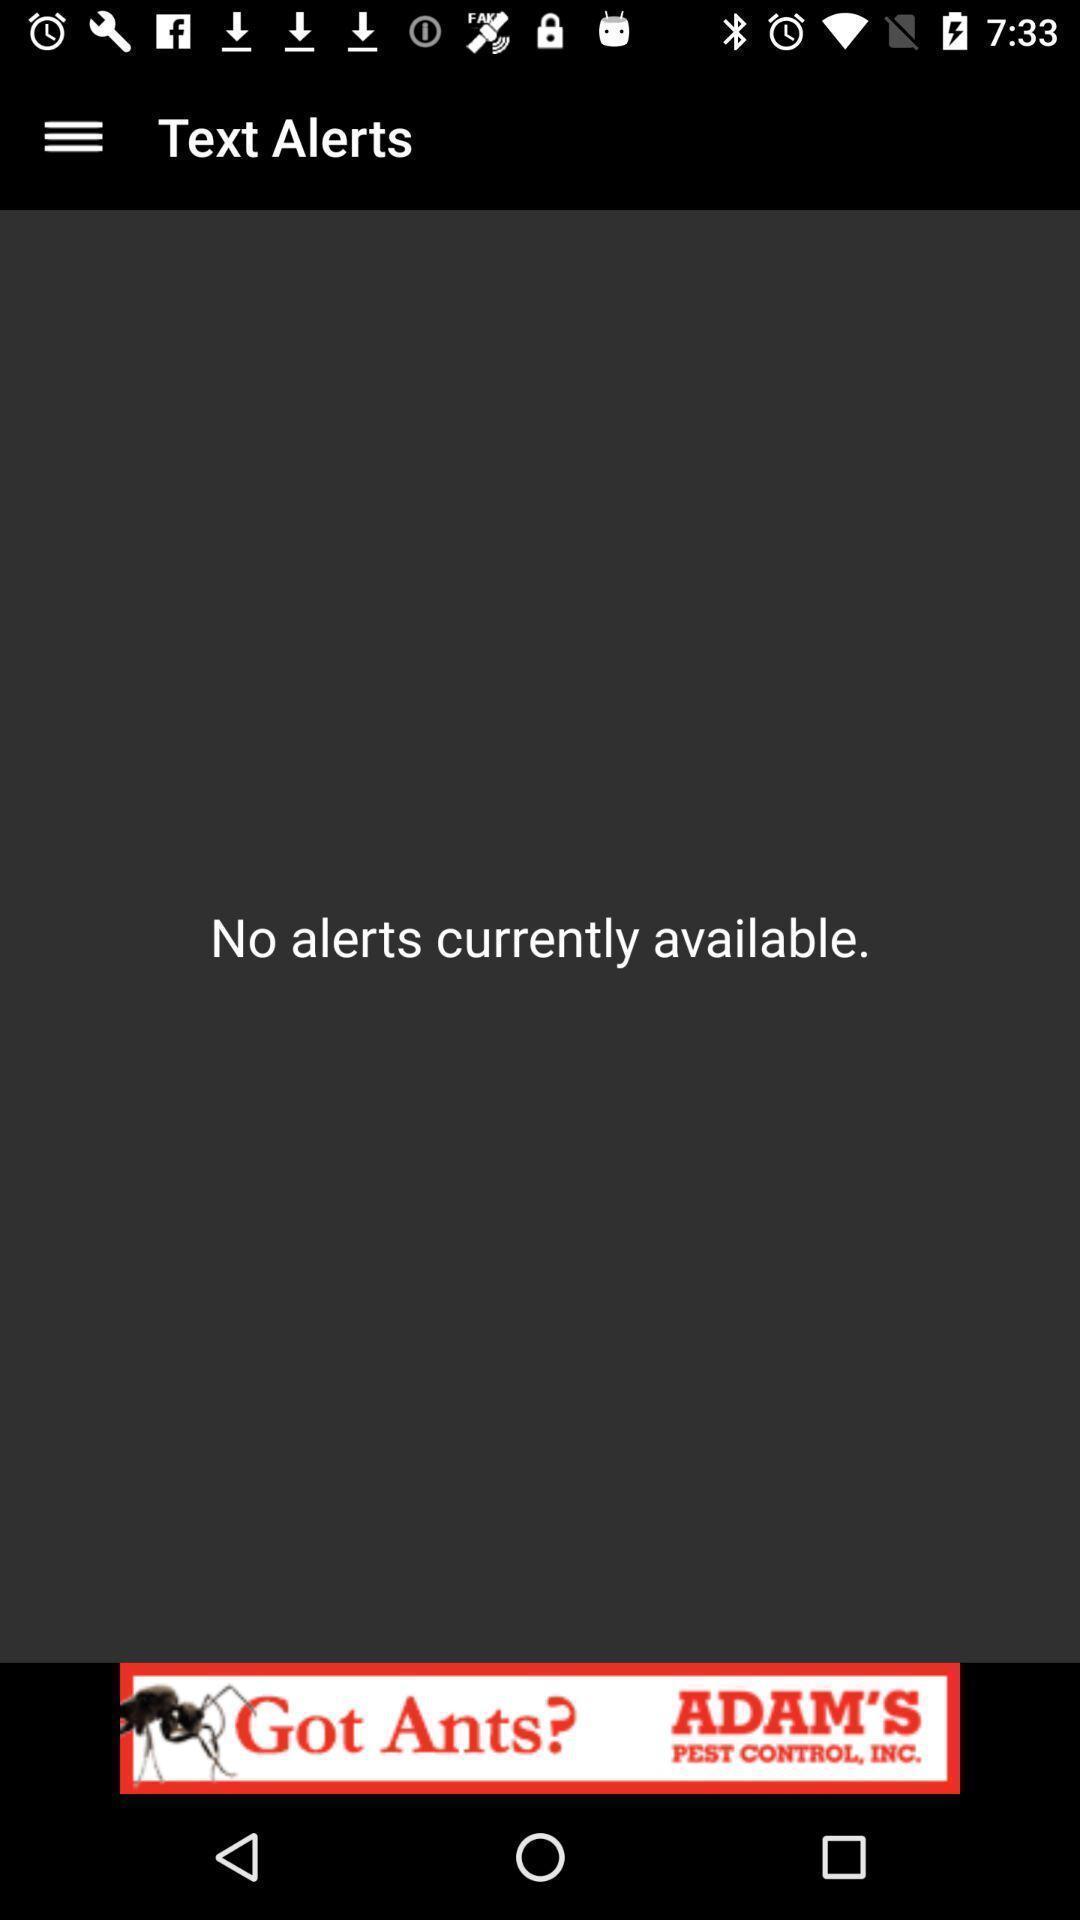Tell me what you see in this picture. Screen displaying about messages alert. 